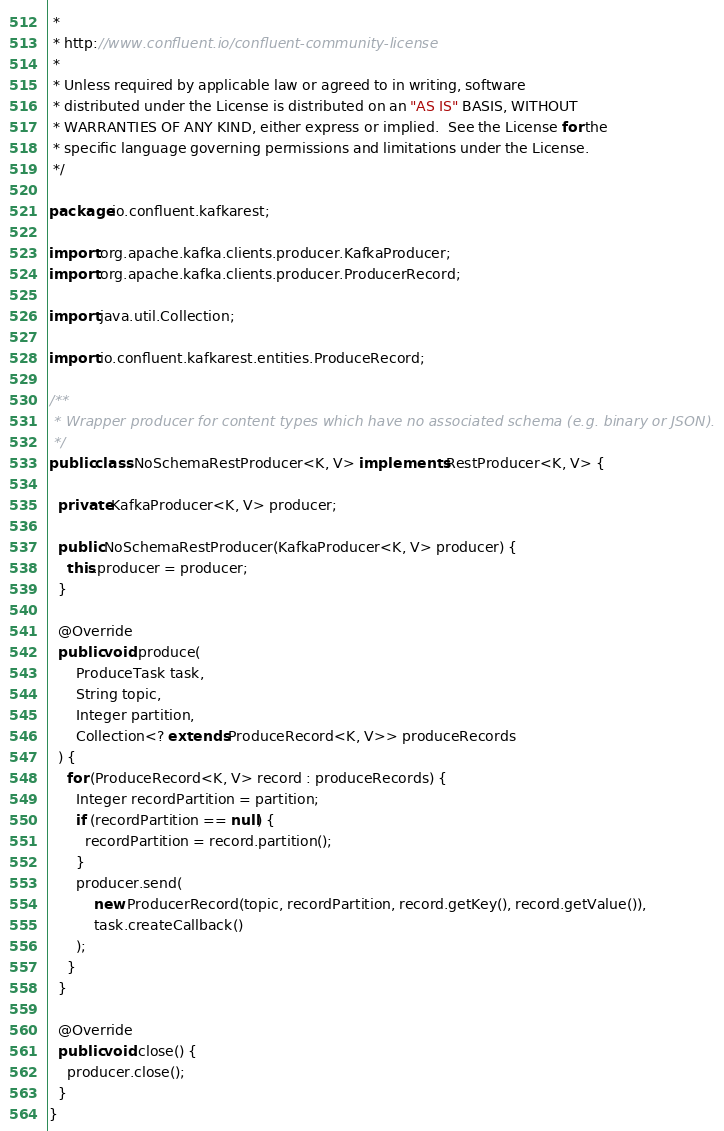Convert code to text. <code><loc_0><loc_0><loc_500><loc_500><_Java_> *
 * http://www.confluent.io/confluent-community-license
 *
 * Unless required by applicable law or agreed to in writing, software
 * distributed under the License is distributed on an "AS IS" BASIS, WITHOUT
 * WARRANTIES OF ANY KIND, either express or implied.  See the License for the
 * specific language governing permissions and limitations under the License.
 */

package io.confluent.kafkarest;

import org.apache.kafka.clients.producer.KafkaProducer;
import org.apache.kafka.clients.producer.ProducerRecord;

import java.util.Collection;

import io.confluent.kafkarest.entities.ProduceRecord;

/**
 * Wrapper producer for content types which have no associated schema (e.g. binary or JSON).
 */
public class NoSchemaRestProducer<K, V> implements RestProducer<K, V> {

  private KafkaProducer<K, V> producer;

  public NoSchemaRestProducer(KafkaProducer<K, V> producer) {
    this.producer = producer;
  }

  @Override
  public void produce(
      ProduceTask task,
      String topic,
      Integer partition,
      Collection<? extends ProduceRecord<K, V>> produceRecords
  ) {
    for (ProduceRecord<K, V> record : produceRecords) {
      Integer recordPartition = partition;
      if (recordPartition == null) {
        recordPartition = record.partition();
      }
      producer.send(
          new ProducerRecord(topic, recordPartition, record.getKey(), record.getValue()),
          task.createCallback()
      );
    }
  }

  @Override
  public void close() {
    producer.close();
  }
}
</code> 